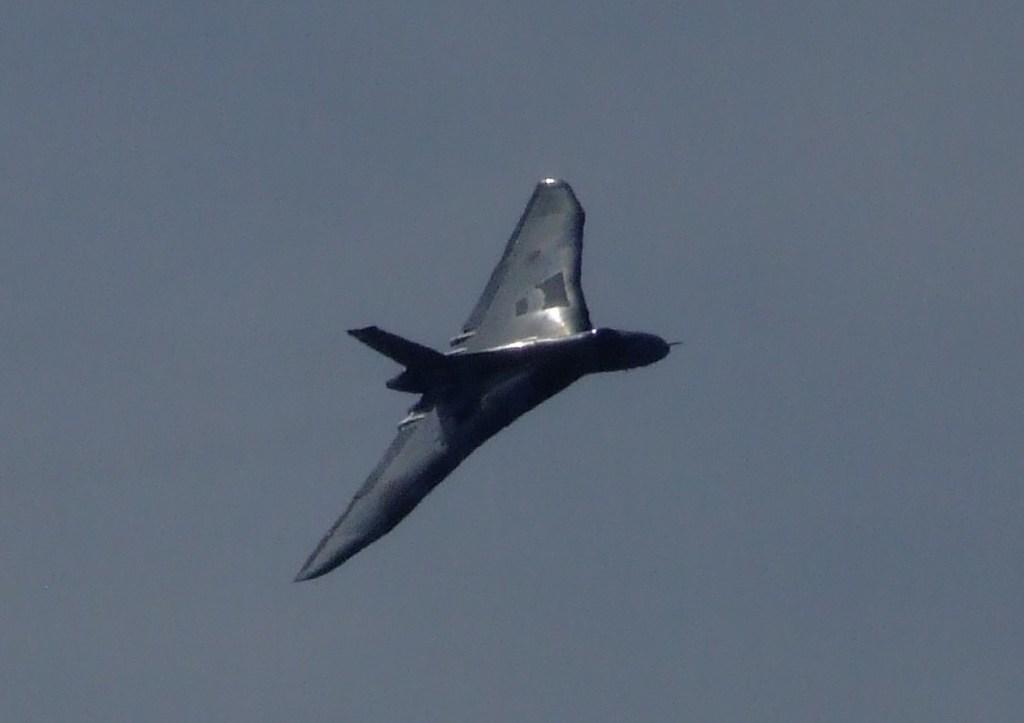What is the main subject of the image? There is an aircraft in the middle of the image. What can be observed about the background of the image? The background color is grey. Can you make any assumptions about the time of day based on the image? The image may have been taken in the evening, as the background color is grey and there might be less light. What type of story is being told by the tramp in the image? There is no tramp present in the image, so no story is being told. Can you describe the insect that is crawling on the aircraft in the image? There is no insect visible on the aircraft in the image. 